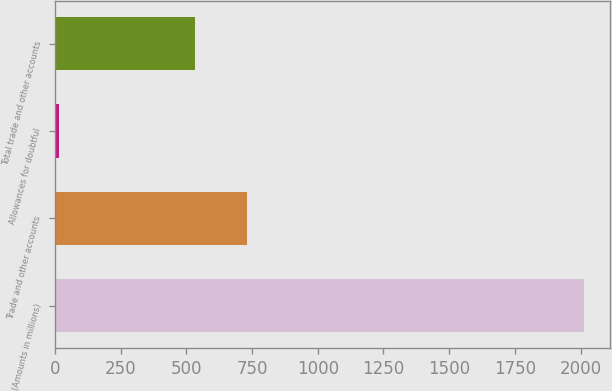Convert chart. <chart><loc_0><loc_0><loc_500><loc_500><bar_chart><fcel>(Amounts in millions)<fcel>Trade and other accounts<fcel>Allowances for doubtful<fcel>Total trade and other accounts<nl><fcel>2013<fcel>731.41<fcel>14.9<fcel>531.6<nl></chart> 